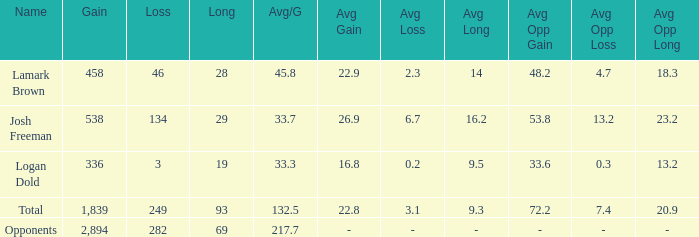Which Avg/G has a Long of 93, and a Loss smaller than 249? None. 